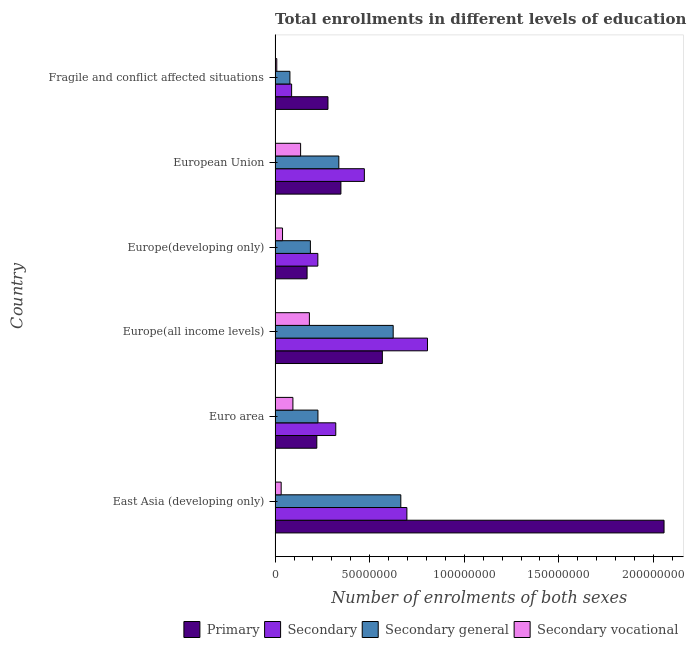Are the number of bars per tick equal to the number of legend labels?
Offer a terse response. Yes. Are the number of bars on each tick of the Y-axis equal?
Provide a short and direct response. Yes. How many bars are there on the 2nd tick from the top?
Your answer should be compact. 4. What is the label of the 3rd group of bars from the top?
Your answer should be very brief. Europe(developing only). What is the number of enrolments in secondary vocational education in East Asia (developing only)?
Your answer should be compact. 3.22e+06. Across all countries, what is the maximum number of enrolments in secondary education?
Provide a short and direct response. 8.06e+07. Across all countries, what is the minimum number of enrolments in secondary vocational education?
Give a very brief answer. 9.00e+05. In which country was the number of enrolments in primary education maximum?
Offer a very short reply. East Asia (developing only). In which country was the number of enrolments in primary education minimum?
Offer a terse response. Europe(developing only). What is the total number of enrolments in secondary education in the graph?
Offer a very short reply. 2.61e+08. What is the difference between the number of enrolments in secondary general education in Europe(all income levels) and that in European Union?
Ensure brevity in your answer.  2.87e+07. What is the difference between the number of enrolments in primary education in Europe(all income levels) and the number of enrolments in secondary general education in Fragile and conflict affected situations?
Keep it short and to the point. 4.89e+07. What is the average number of enrolments in secondary general education per country?
Provide a succinct answer. 3.53e+07. What is the difference between the number of enrolments in secondary vocational education and number of enrolments in secondary general education in East Asia (developing only)?
Give a very brief answer. -6.32e+07. What is the ratio of the number of enrolments in secondary vocational education in Europe(all income levels) to that in Fragile and conflict affected situations?
Your answer should be very brief. 20.14. Is the difference between the number of enrolments in secondary general education in Europe(all income levels) and Europe(developing only) greater than the difference between the number of enrolments in primary education in Europe(all income levels) and Europe(developing only)?
Keep it short and to the point. Yes. What is the difference between the highest and the second highest number of enrolments in primary education?
Provide a succinct answer. 1.49e+08. What is the difference between the highest and the lowest number of enrolments in secondary vocational education?
Make the answer very short. 1.72e+07. In how many countries, is the number of enrolments in secondary education greater than the average number of enrolments in secondary education taken over all countries?
Give a very brief answer. 3. Is it the case that in every country, the sum of the number of enrolments in secondary general education and number of enrolments in secondary vocational education is greater than the sum of number of enrolments in secondary education and number of enrolments in primary education?
Make the answer very short. No. What does the 2nd bar from the top in Europe(all income levels) represents?
Keep it short and to the point. Secondary general. What does the 3rd bar from the bottom in European Union represents?
Provide a succinct answer. Secondary general. How many bars are there?
Provide a short and direct response. 24. How many countries are there in the graph?
Your response must be concise. 6. What is the difference between two consecutive major ticks on the X-axis?
Offer a very short reply. 5.00e+07. Does the graph contain any zero values?
Your answer should be compact. No. Does the graph contain grids?
Keep it short and to the point. No. Where does the legend appear in the graph?
Offer a very short reply. Bottom right. How many legend labels are there?
Ensure brevity in your answer.  4. What is the title of the graph?
Provide a succinct answer. Total enrollments in different levels of education as per the survey of 1982. What is the label or title of the X-axis?
Provide a short and direct response. Number of enrolments of both sexes. What is the label or title of the Y-axis?
Ensure brevity in your answer.  Country. What is the Number of enrolments of both sexes of Primary in East Asia (developing only)?
Give a very brief answer. 2.06e+08. What is the Number of enrolments of both sexes of Secondary in East Asia (developing only)?
Your response must be concise. 6.97e+07. What is the Number of enrolments of both sexes of Secondary general in East Asia (developing only)?
Ensure brevity in your answer.  6.65e+07. What is the Number of enrolments of both sexes of Secondary vocational in East Asia (developing only)?
Provide a succinct answer. 3.22e+06. What is the Number of enrolments of both sexes of Primary in Euro area?
Ensure brevity in your answer.  2.21e+07. What is the Number of enrolments of both sexes of Secondary in Euro area?
Offer a very short reply. 3.21e+07. What is the Number of enrolments of both sexes of Secondary general in Euro area?
Your answer should be very brief. 2.27e+07. What is the Number of enrolments of both sexes of Secondary vocational in Euro area?
Your answer should be compact. 9.42e+06. What is the Number of enrolments of both sexes in Primary in Europe(all income levels)?
Offer a terse response. 5.67e+07. What is the Number of enrolments of both sexes in Secondary in Europe(all income levels)?
Offer a very short reply. 8.06e+07. What is the Number of enrolments of both sexes of Secondary general in Europe(all income levels)?
Make the answer very short. 6.24e+07. What is the Number of enrolments of both sexes of Secondary vocational in Europe(all income levels)?
Offer a very short reply. 1.81e+07. What is the Number of enrolments of both sexes of Primary in Europe(developing only)?
Offer a very short reply. 1.69e+07. What is the Number of enrolments of both sexes in Secondary in Europe(developing only)?
Your response must be concise. 2.26e+07. What is the Number of enrolments of both sexes of Secondary general in Europe(developing only)?
Give a very brief answer. 1.87e+07. What is the Number of enrolments of both sexes in Secondary vocational in Europe(developing only)?
Make the answer very short. 3.94e+06. What is the Number of enrolments of both sexes in Primary in European Union?
Your answer should be very brief. 3.48e+07. What is the Number of enrolments of both sexes in Secondary in European Union?
Your response must be concise. 4.72e+07. What is the Number of enrolments of both sexes in Secondary general in European Union?
Offer a terse response. 3.37e+07. What is the Number of enrolments of both sexes in Secondary vocational in European Union?
Ensure brevity in your answer.  1.35e+07. What is the Number of enrolments of both sexes in Primary in Fragile and conflict affected situations?
Make the answer very short. 2.80e+07. What is the Number of enrolments of both sexes of Secondary in Fragile and conflict affected situations?
Your answer should be very brief. 8.74e+06. What is the Number of enrolments of both sexes in Secondary general in Fragile and conflict affected situations?
Ensure brevity in your answer.  7.84e+06. What is the Number of enrolments of both sexes in Secondary vocational in Fragile and conflict affected situations?
Your answer should be compact. 9.00e+05. Across all countries, what is the maximum Number of enrolments of both sexes in Primary?
Provide a succinct answer. 2.06e+08. Across all countries, what is the maximum Number of enrolments of both sexes in Secondary?
Your response must be concise. 8.06e+07. Across all countries, what is the maximum Number of enrolments of both sexes in Secondary general?
Provide a short and direct response. 6.65e+07. Across all countries, what is the maximum Number of enrolments of both sexes of Secondary vocational?
Give a very brief answer. 1.81e+07. Across all countries, what is the minimum Number of enrolments of both sexes in Primary?
Your answer should be very brief. 1.69e+07. Across all countries, what is the minimum Number of enrolments of both sexes of Secondary?
Provide a short and direct response. 8.74e+06. Across all countries, what is the minimum Number of enrolments of both sexes in Secondary general?
Ensure brevity in your answer.  7.84e+06. Across all countries, what is the minimum Number of enrolments of both sexes of Secondary vocational?
Ensure brevity in your answer.  9.00e+05. What is the total Number of enrolments of both sexes of Primary in the graph?
Offer a very short reply. 3.64e+08. What is the total Number of enrolments of both sexes in Secondary in the graph?
Your answer should be very brief. 2.61e+08. What is the total Number of enrolments of both sexes in Secondary general in the graph?
Your answer should be very brief. 2.12e+08. What is the total Number of enrolments of both sexes of Secondary vocational in the graph?
Your response must be concise. 4.91e+07. What is the difference between the Number of enrolments of both sexes of Primary in East Asia (developing only) and that in Euro area?
Your response must be concise. 1.84e+08. What is the difference between the Number of enrolments of both sexes in Secondary in East Asia (developing only) and that in Euro area?
Your answer should be compact. 3.76e+07. What is the difference between the Number of enrolments of both sexes in Secondary general in East Asia (developing only) and that in Euro area?
Give a very brief answer. 4.38e+07. What is the difference between the Number of enrolments of both sexes of Secondary vocational in East Asia (developing only) and that in Euro area?
Provide a short and direct response. -6.20e+06. What is the difference between the Number of enrolments of both sexes of Primary in East Asia (developing only) and that in Europe(all income levels)?
Your response must be concise. 1.49e+08. What is the difference between the Number of enrolments of both sexes in Secondary in East Asia (developing only) and that in Europe(all income levels)?
Offer a very short reply. -1.09e+07. What is the difference between the Number of enrolments of both sexes in Secondary general in East Asia (developing only) and that in Europe(all income levels)?
Make the answer very short. 4.03e+06. What is the difference between the Number of enrolments of both sexes of Secondary vocational in East Asia (developing only) and that in Europe(all income levels)?
Ensure brevity in your answer.  -1.49e+07. What is the difference between the Number of enrolments of both sexes of Primary in East Asia (developing only) and that in Europe(developing only)?
Your answer should be very brief. 1.89e+08. What is the difference between the Number of enrolments of both sexes in Secondary in East Asia (developing only) and that in Europe(developing only)?
Provide a short and direct response. 4.71e+07. What is the difference between the Number of enrolments of both sexes of Secondary general in East Asia (developing only) and that in Europe(developing only)?
Ensure brevity in your answer.  4.78e+07. What is the difference between the Number of enrolments of both sexes of Secondary vocational in East Asia (developing only) and that in Europe(developing only)?
Your answer should be very brief. -7.19e+05. What is the difference between the Number of enrolments of both sexes in Primary in East Asia (developing only) and that in European Union?
Give a very brief answer. 1.71e+08. What is the difference between the Number of enrolments of both sexes of Secondary in East Asia (developing only) and that in European Union?
Your answer should be compact. 2.25e+07. What is the difference between the Number of enrolments of both sexes of Secondary general in East Asia (developing only) and that in European Union?
Your response must be concise. 3.28e+07. What is the difference between the Number of enrolments of both sexes of Secondary vocational in East Asia (developing only) and that in European Union?
Provide a short and direct response. -1.03e+07. What is the difference between the Number of enrolments of both sexes of Primary in East Asia (developing only) and that in Fragile and conflict affected situations?
Keep it short and to the point. 1.78e+08. What is the difference between the Number of enrolments of both sexes in Secondary in East Asia (developing only) and that in Fragile and conflict affected situations?
Provide a short and direct response. 6.09e+07. What is the difference between the Number of enrolments of both sexes in Secondary general in East Asia (developing only) and that in Fragile and conflict affected situations?
Offer a terse response. 5.86e+07. What is the difference between the Number of enrolments of both sexes of Secondary vocational in East Asia (developing only) and that in Fragile and conflict affected situations?
Keep it short and to the point. 2.32e+06. What is the difference between the Number of enrolments of both sexes of Primary in Euro area and that in Europe(all income levels)?
Offer a very short reply. -3.46e+07. What is the difference between the Number of enrolments of both sexes in Secondary in Euro area and that in Europe(all income levels)?
Provide a succinct answer. -4.85e+07. What is the difference between the Number of enrolments of both sexes of Secondary general in Euro area and that in Europe(all income levels)?
Provide a short and direct response. -3.98e+07. What is the difference between the Number of enrolments of both sexes of Secondary vocational in Euro area and that in Europe(all income levels)?
Make the answer very short. -8.71e+06. What is the difference between the Number of enrolments of both sexes in Primary in Euro area and that in Europe(developing only)?
Make the answer very short. 5.14e+06. What is the difference between the Number of enrolments of both sexes of Secondary in Euro area and that in Europe(developing only)?
Your response must be concise. 9.47e+06. What is the difference between the Number of enrolments of both sexes of Secondary general in Euro area and that in Europe(developing only)?
Keep it short and to the point. 3.99e+06. What is the difference between the Number of enrolments of both sexes of Secondary vocational in Euro area and that in Europe(developing only)?
Make the answer very short. 5.48e+06. What is the difference between the Number of enrolments of both sexes of Primary in Euro area and that in European Union?
Ensure brevity in your answer.  -1.27e+07. What is the difference between the Number of enrolments of both sexes of Secondary in Euro area and that in European Union?
Make the answer very short. -1.51e+07. What is the difference between the Number of enrolments of both sexes of Secondary general in Euro area and that in European Union?
Ensure brevity in your answer.  -1.10e+07. What is the difference between the Number of enrolments of both sexes of Secondary vocational in Euro area and that in European Union?
Your answer should be compact. -4.08e+06. What is the difference between the Number of enrolments of both sexes of Primary in Euro area and that in Fragile and conflict affected situations?
Your response must be concise. -5.90e+06. What is the difference between the Number of enrolments of both sexes of Secondary in Euro area and that in Fragile and conflict affected situations?
Give a very brief answer. 2.33e+07. What is the difference between the Number of enrolments of both sexes in Secondary general in Euro area and that in Fragile and conflict affected situations?
Provide a succinct answer. 1.48e+07. What is the difference between the Number of enrolments of both sexes in Secondary vocational in Euro area and that in Fragile and conflict affected situations?
Provide a succinct answer. 8.52e+06. What is the difference between the Number of enrolments of both sexes of Primary in Europe(all income levels) and that in Europe(developing only)?
Provide a short and direct response. 3.98e+07. What is the difference between the Number of enrolments of both sexes of Secondary in Europe(all income levels) and that in Europe(developing only)?
Your answer should be very brief. 5.80e+07. What is the difference between the Number of enrolments of both sexes of Secondary general in Europe(all income levels) and that in Europe(developing only)?
Your answer should be very brief. 4.38e+07. What is the difference between the Number of enrolments of both sexes in Secondary vocational in Europe(all income levels) and that in Europe(developing only)?
Offer a very short reply. 1.42e+07. What is the difference between the Number of enrolments of both sexes in Primary in Europe(all income levels) and that in European Union?
Offer a terse response. 2.19e+07. What is the difference between the Number of enrolments of both sexes in Secondary in Europe(all income levels) and that in European Union?
Make the answer very short. 3.34e+07. What is the difference between the Number of enrolments of both sexes of Secondary general in Europe(all income levels) and that in European Union?
Ensure brevity in your answer.  2.87e+07. What is the difference between the Number of enrolments of both sexes in Secondary vocational in Europe(all income levels) and that in European Union?
Make the answer very short. 4.64e+06. What is the difference between the Number of enrolments of both sexes of Primary in Europe(all income levels) and that in Fragile and conflict affected situations?
Ensure brevity in your answer.  2.87e+07. What is the difference between the Number of enrolments of both sexes of Secondary in Europe(all income levels) and that in Fragile and conflict affected situations?
Provide a succinct answer. 7.18e+07. What is the difference between the Number of enrolments of both sexes of Secondary general in Europe(all income levels) and that in Fragile and conflict affected situations?
Your answer should be compact. 5.46e+07. What is the difference between the Number of enrolments of both sexes in Secondary vocational in Europe(all income levels) and that in Fragile and conflict affected situations?
Make the answer very short. 1.72e+07. What is the difference between the Number of enrolments of both sexes of Primary in Europe(developing only) and that in European Union?
Provide a succinct answer. -1.79e+07. What is the difference between the Number of enrolments of both sexes in Secondary in Europe(developing only) and that in European Union?
Give a very brief answer. -2.46e+07. What is the difference between the Number of enrolments of both sexes of Secondary general in Europe(developing only) and that in European Union?
Give a very brief answer. -1.50e+07. What is the difference between the Number of enrolments of both sexes in Secondary vocational in Europe(developing only) and that in European Union?
Offer a very short reply. -9.56e+06. What is the difference between the Number of enrolments of both sexes in Primary in Europe(developing only) and that in Fragile and conflict affected situations?
Your answer should be very brief. -1.10e+07. What is the difference between the Number of enrolments of both sexes in Secondary in Europe(developing only) and that in Fragile and conflict affected situations?
Provide a short and direct response. 1.39e+07. What is the difference between the Number of enrolments of both sexes in Secondary general in Europe(developing only) and that in Fragile and conflict affected situations?
Your answer should be very brief. 1.08e+07. What is the difference between the Number of enrolments of both sexes of Secondary vocational in Europe(developing only) and that in Fragile and conflict affected situations?
Make the answer very short. 3.04e+06. What is the difference between the Number of enrolments of both sexes of Primary in European Union and that in Fragile and conflict affected situations?
Your response must be concise. 6.83e+06. What is the difference between the Number of enrolments of both sexes of Secondary in European Union and that in Fragile and conflict affected situations?
Keep it short and to the point. 3.85e+07. What is the difference between the Number of enrolments of both sexes in Secondary general in European Union and that in Fragile and conflict affected situations?
Ensure brevity in your answer.  2.59e+07. What is the difference between the Number of enrolments of both sexes of Secondary vocational in European Union and that in Fragile and conflict affected situations?
Make the answer very short. 1.26e+07. What is the difference between the Number of enrolments of both sexes of Primary in East Asia (developing only) and the Number of enrolments of both sexes of Secondary in Euro area?
Keep it short and to the point. 1.74e+08. What is the difference between the Number of enrolments of both sexes of Primary in East Asia (developing only) and the Number of enrolments of both sexes of Secondary general in Euro area?
Offer a very short reply. 1.83e+08. What is the difference between the Number of enrolments of both sexes of Primary in East Asia (developing only) and the Number of enrolments of both sexes of Secondary vocational in Euro area?
Keep it short and to the point. 1.96e+08. What is the difference between the Number of enrolments of both sexes in Secondary in East Asia (developing only) and the Number of enrolments of both sexes in Secondary general in Euro area?
Offer a very short reply. 4.70e+07. What is the difference between the Number of enrolments of both sexes of Secondary in East Asia (developing only) and the Number of enrolments of both sexes of Secondary vocational in Euro area?
Your answer should be very brief. 6.03e+07. What is the difference between the Number of enrolments of both sexes of Secondary general in East Asia (developing only) and the Number of enrolments of both sexes of Secondary vocational in Euro area?
Offer a very short reply. 5.70e+07. What is the difference between the Number of enrolments of both sexes of Primary in East Asia (developing only) and the Number of enrolments of both sexes of Secondary in Europe(all income levels)?
Offer a very short reply. 1.25e+08. What is the difference between the Number of enrolments of both sexes of Primary in East Asia (developing only) and the Number of enrolments of both sexes of Secondary general in Europe(all income levels)?
Keep it short and to the point. 1.43e+08. What is the difference between the Number of enrolments of both sexes of Primary in East Asia (developing only) and the Number of enrolments of both sexes of Secondary vocational in Europe(all income levels)?
Offer a very short reply. 1.87e+08. What is the difference between the Number of enrolments of both sexes of Secondary in East Asia (developing only) and the Number of enrolments of both sexes of Secondary general in Europe(all income levels)?
Provide a succinct answer. 7.25e+06. What is the difference between the Number of enrolments of both sexes of Secondary in East Asia (developing only) and the Number of enrolments of both sexes of Secondary vocational in Europe(all income levels)?
Your answer should be compact. 5.15e+07. What is the difference between the Number of enrolments of both sexes of Secondary general in East Asia (developing only) and the Number of enrolments of both sexes of Secondary vocational in Europe(all income levels)?
Ensure brevity in your answer.  4.83e+07. What is the difference between the Number of enrolments of both sexes in Primary in East Asia (developing only) and the Number of enrolments of both sexes in Secondary in Europe(developing only)?
Offer a terse response. 1.83e+08. What is the difference between the Number of enrolments of both sexes of Primary in East Asia (developing only) and the Number of enrolments of both sexes of Secondary general in Europe(developing only)?
Keep it short and to the point. 1.87e+08. What is the difference between the Number of enrolments of both sexes in Primary in East Asia (developing only) and the Number of enrolments of both sexes in Secondary vocational in Europe(developing only)?
Your answer should be very brief. 2.02e+08. What is the difference between the Number of enrolments of both sexes of Secondary in East Asia (developing only) and the Number of enrolments of both sexes of Secondary general in Europe(developing only)?
Ensure brevity in your answer.  5.10e+07. What is the difference between the Number of enrolments of both sexes of Secondary in East Asia (developing only) and the Number of enrolments of both sexes of Secondary vocational in Europe(developing only)?
Your answer should be compact. 6.57e+07. What is the difference between the Number of enrolments of both sexes in Secondary general in East Asia (developing only) and the Number of enrolments of both sexes in Secondary vocational in Europe(developing only)?
Give a very brief answer. 6.25e+07. What is the difference between the Number of enrolments of both sexes of Primary in East Asia (developing only) and the Number of enrolments of both sexes of Secondary in European Union?
Give a very brief answer. 1.58e+08. What is the difference between the Number of enrolments of both sexes in Primary in East Asia (developing only) and the Number of enrolments of both sexes in Secondary general in European Union?
Provide a short and direct response. 1.72e+08. What is the difference between the Number of enrolments of both sexes of Primary in East Asia (developing only) and the Number of enrolments of both sexes of Secondary vocational in European Union?
Make the answer very short. 1.92e+08. What is the difference between the Number of enrolments of both sexes of Secondary in East Asia (developing only) and the Number of enrolments of both sexes of Secondary general in European Union?
Make the answer very short. 3.60e+07. What is the difference between the Number of enrolments of both sexes in Secondary in East Asia (developing only) and the Number of enrolments of both sexes in Secondary vocational in European Union?
Your answer should be compact. 5.62e+07. What is the difference between the Number of enrolments of both sexes in Secondary general in East Asia (developing only) and the Number of enrolments of both sexes in Secondary vocational in European Union?
Offer a terse response. 5.30e+07. What is the difference between the Number of enrolments of both sexes of Primary in East Asia (developing only) and the Number of enrolments of both sexes of Secondary in Fragile and conflict affected situations?
Keep it short and to the point. 1.97e+08. What is the difference between the Number of enrolments of both sexes of Primary in East Asia (developing only) and the Number of enrolments of both sexes of Secondary general in Fragile and conflict affected situations?
Make the answer very short. 1.98e+08. What is the difference between the Number of enrolments of both sexes in Primary in East Asia (developing only) and the Number of enrolments of both sexes in Secondary vocational in Fragile and conflict affected situations?
Your answer should be very brief. 2.05e+08. What is the difference between the Number of enrolments of both sexes of Secondary in East Asia (developing only) and the Number of enrolments of both sexes of Secondary general in Fragile and conflict affected situations?
Give a very brief answer. 6.18e+07. What is the difference between the Number of enrolments of both sexes of Secondary in East Asia (developing only) and the Number of enrolments of both sexes of Secondary vocational in Fragile and conflict affected situations?
Offer a very short reply. 6.88e+07. What is the difference between the Number of enrolments of both sexes of Secondary general in East Asia (developing only) and the Number of enrolments of both sexes of Secondary vocational in Fragile and conflict affected situations?
Ensure brevity in your answer.  6.56e+07. What is the difference between the Number of enrolments of both sexes in Primary in Euro area and the Number of enrolments of both sexes in Secondary in Europe(all income levels)?
Your answer should be very brief. -5.85e+07. What is the difference between the Number of enrolments of both sexes of Primary in Euro area and the Number of enrolments of both sexes of Secondary general in Europe(all income levels)?
Keep it short and to the point. -4.04e+07. What is the difference between the Number of enrolments of both sexes in Primary in Euro area and the Number of enrolments of both sexes in Secondary vocational in Europe(all income levels)?
Provide a short and direct response. 3.93e+06. What is the difference between the Number of enrolments of both sexes of Secondary in Euro area and the Number of enrolments of both sexes of Secondary general in Europe(all income levels)?
Provide a succinct answer. -3.04e+07. What is the difference between the Number of enrolments of both sexes in Secondary in Euro area and the Number of enrolments of both sexes in Secondary vocational in Europe(all income levels)?
Your answer should be very brief. 1.39e+07. What is the difference between the Number of enrolments of both sexes of Secondary general in Euro area and the Number of enrolments of both sexes of Secondary vocational in Europe(all income levels)?
Offer a very short reply. 4.52e+06. What is the difference between the Number of enrolments of both sexes of Primary in Euro area and the Number of enrolments of both sexes of Secondary in Europe(developing only)?
Your answer should be compact. -5.44e+05. What is the difference between the Number of enrolments of both sexes of Primary in Euro area and the Number of enrolments of both sexes of Secondary general in Europe(developing only)?
Offer a very short reply. 3.39e+06. What is the difference between the Number of enrolments of both sexes in Primary in Euro area and the Number of enrolments of both sexes in Secondary vocational in Europe(developing only)?
Provide a short and direct response. 1.81e+07. What is the difference between the Number of enrolments of both sexes in Secondary in Euro area and the Number of enrolments of both sexes in Secondary general in Europe(developing only)?
Keep it short and to the point. 1.34e+07. What is the difference between the Number of enrolments of both sexes in Secondary in Euro area and the Number of enrolments of both sexes in Secondary vocational in Europe(developing only)?
Ensure brevity in your answer.  2.81e+07. What is the difference between the Number of enrolments of both sexes in Secondary general in Euro area and the Number of enrolments of both sexes in Secondary vocational in Europe(developing only)?
Provide a succinct answer. 1.87e+07. What is the difference between the Number of enrolments of both sexes in Primary in Euro area and the Number of enrolments of both sexes in Secondary in European Union?
Make the answer very short. -2.51e+07. What is the difference between the Number of enrolments of both sexes in Primary in Euro area and the Number of enrolments of both sexes in Secondary general in European Union?
Keep it short and to the point. -1.16e+07. What is the difference between the Number of enrolments of both sexes in Primary in Euro area and the Number of enrolments of both sexes in Secondary vocational in European Union?
Make the answer very short. 8.57e+06. What is the difference between the Number of enrolments of both sexes of Secondary in Euro area and the Number of enrolments of both sexes of Secondary general in European Union?
Your response must be concise. -1.62e+06. What is the difference between the Number of enrolments of both sexes in Secondary in Euro area and the Number of enrolments of both sexes in Secondary vocational in European Union?
Give a very brief answer. 1.86e+07. What is the difference between the Number of enrolments of both sexes in Secondary general in Euro area and the Number of enrolments of both sexes in Secondary vocational in European Union?
Provide a short and direct response. 9.16e+06. What is the difference between the Number of enrolments of both sexes in Primary in Euro area and the Number of enrolments of both sexes in Secondary in Fragile and conflict affected situations?
Keep it short and to the point. 1.33e+07. What is the difference between the Number of enrolments of both sexes in Primary in Euro area and the Number of enrolments of both sexes in Secondary general in Fragile and conflict affected situations?
Provide a short and direct response. 1.42e+07. What is the difference between the Number of enrolments of both sexes in Primary in Euro area and the Number of enrolments of both sexes in Secondary vocational in Fragile and conflict affected situations?
Give a very brief answer. 2.12e+07. What is the difference between the Number of enrolments of both sexes in Secondary in Euro area and the Number of enrolments of both sexes in Secondary general in Fragile and conflict affected situations?
Make the answer very short. 2.42e+07. What is the difference between the Number of enrolments of both sexes in Secondary in Euro area and the Number of enrolments of both sexes in Secondary vocational in Fragile and conflict affected situations?
Offer a terse response. 3.12e+07. What is the difference between the Number of enrolments of both sexes of Secondary general in Euro area and the Number of enrolments of both sexes of Secondary vocational in Fragile and conflict affected situations?
Your response must be concise. 2.18e+07. What is the difference between the Number of enrolments of both sexes in Primary in Europe(all income levels) and the Number of enrolments of both sexes in Secondary in Europe(developing only)?
Your answer should be very brief. 3.41e+07. What is the difference between the Number of enrolments of both sexes of Primary in Europe(all income levels) and the Number of enrolments of both sexes of Secondary general in Europe(developing only)?
Make the answer very short. 3.80e+07. What is the difference between the Number of enrolments of both sexes in Primary in Europe(all income levels) and the Number of enrolments of both sexes in Secondary vocational in Europe(developing only)?
Offer a terse response. 5.28e+07. What is the difference between the Number of enrolments of both sexes in Secondary in Europe(all income levels) and the Number of enrolments of both sexes in Secondary general in Europe(developing only)?
Offer a very short reply. 6.19e+07. What is the difference between the Number of enrolments of both sexes in Secondary in Europe(all income levels) and the Number of enrolments of both sexes in Secondary vocational in Europe(developing only)?
Make the answer very short. 7.66e+07. What is the difference between the Number of enrolments of both sexes in Secondary general in Europe(all income levels) and the Number of enrolments of both sexes in Secondary vocational in Europe(developing only)?
Give a very brief answer. 5.85e+07. What is the difference between the Number of enrolments of both sexes in Primary in Europe(all income levels) and the Number of enrolments of both sexes in Secondary in European Union?
Keep it short and to the point. 9.52e+06. What is the difference between the Number of enrolments of both sexes in Primary in Europe(all income levels) and the Number of enrolments of both sexes in Secondary general in European Union?
Keep it short and to the point. 2.30e+07. What is the difference between the Number of enrolments of both sexes of Primary in Europe(all income levels) and the Number of enrolments of both sexes of Secondary vocational in European Union?
Give a very brief answer. 4.32e+07. What is the difference between the Number of enrolments of both sexes of Secondary in Europe(all income levels) and the Number of enrolments of both sexes of Secondary general in European Union?
Provide a short and direct response. 4.69e+07. What is the difference between the Number of enrolments of both sexes of Secondary in Europe(all income levels) and the Number of enrolments of both sexes of Secondary vocational in European Union?
Offer a terse response. 6.71e+07. What is the difference between the Number of enrolments of both sexes of Secondary general in Europe(all income levels) and the Number of enrolments of both sexes of Secondary vocational in European Union?
Make the answer very short. 4.89e+07. What is the difference between the Number of enrolments of both sexes in Primary in Europe(all income levels) and the Number of enrolments of both sexes in Secondary in Fragile and conflict affected situations?
Ensure brevity in your answer.  4.80e+07. What is the difference between the Number of enrolments of both sexes in Primary in Europe(all income levels) and the Number of enrolments of both sexes in Secondary general in Fragile and conflict affected situations?
Your answer should be compact. 4.89e+07. What is the difference between the Number of enrolments of both sexes of Primary in Europe(all income levels) and the Number of enrolments of both sexes of Secondary vocational in Fragile and conflict affected situations?
Keep it short and to the point. 5.58e+07. What is the difference between the Number of enrolments of both sexes in Secondary in Europe(all income levels) and the Number of enrolments of both sexes in Secondary general in Fragile and conflict affected situations?
Keep it short and to the point. 7.27e+07. What is the difference between the Number of enrolments of both sexes of Secondary in Europe(all income levels) and the Number of enrolments of both sexes of Secondary vocational in Fragile and conflict affected situations?
Your answer should be very brief. 7.97e+07. What is the difference between the Number of enrolments of both sexes of Secondary general in Europe(all income levels) and the Number of enrolments of both sexes of Secondary vocational in Fragile and conflict affected situations?
Provide a succinct answer. 6.15e+07. What is the difference between the Number of enrolments of both sexes in Primary in Europe(developing only) and the Number of enrolments of both sexes in Secondary in European Union?
Ensure brevity in your answer.  -3.03e+07. What is the difference between the Number of enrolments of both sexes of Primary in Europe(developing only) and the Number of enrolments of both sexes of Secondary general in European Union?
Keep it short and to the point. -1.68e+07. What is the difference between the Number of enrolments of both sexes of Primary in Europe(developing only) and the Number of enrolments of both sexes of Secondary vocational in European Union?
Ensure brevity in your answer.  3.42e+06. What is the difference between the Number of enrolments of both sexes of Secondary in Europe(developing only) and the Number of enrolments of both sexes of Secondary general in European Union?
Make the answer very short. -1.11e+07. What is the difference between the Number of enrolments of both sexes in Secondary in Europe(developing only) and the Number of enrolments of both sexes in Secondary vocational in European Union?
Make the answer very short. 9.11e+06. What is the difference between the Number of enrolments of both sexes of Secondary general in Europe(developing only) and the Number of enrolments of both sexes of Secondary vocational in European Union?
Offer a terse response. 5.17e+06. What is the difference between the Number of enrolments of both sexes in Primary in Europe(developing only) and the Number of enrolments of both sexes in Secondary in Fragile and conflict affected situations?
Make the answer very short. 8.18e+06. What is the difference between the Number of enrolments of both sexes of Primary in Europe(developing only) and the Number of enrolments of both sexes of Secondary general in Fragile and conflict affected situations?
Offer a terse response. 9.08e+06. What is the difference between the Number of enrolments of both sexes of Primary in Europe(developing only) and the Number of enrolments of both sexes of Secondary vocational in Fragile and conflict affected situations?
Your answer should be compact. 1.60e+07. What is the difference between the Number of enrolments of both sexes in Secondary in Europe(developing only) and the Number of enrolments of both sexes in Secondary general in Fragile and conflict affected situations?
Keep it short and to the point. 1.48e+07. What is the difference between the Number of enrolments of both sexes in Secondary in Europe(developing only) and the Number of enrolments of both sexes in Secondary vocational in Fragile and conflict affected situations?
Provide a succinct answer. 2.17e+07. What is the difference between the Number of enrolments of both sexes of Secondary general in Europe(developing only) and the Number of enrolments of both sexes of Secondary vocational in Fragile and conflict affected situations?
Your response must be concise. 1.78e+07. What is the difference between the Number of enrolments of both sexes in Primary in European Union and the Number of enrolments of both sexes in Secondary in Fragile and conflict affected situations?
Ensure brevity in your answer.  2.61e+07. What is the difference between the Number of enrolments of both sexes of Primary in European Union and the Number of enrolments of both sexes of Secondary general in Fragile and conflict affected situations?
Offer a very short reply. 2.70e+07. What is the difference between the Number of enrolments of both sexes in Primary in European Union and the Number of enrolments of both sexes in Secondary vocational in Fragile and conflict affected situations?
Your response must be concise. 3.39e+07. What is the difference between the Number of enrolments of both sexes in Secondary in European Union and the Number of enrolments of both sexes in Secondary general in Fragile and conflict affected situations?
Your answer should be very brief. 3.94e+07. What is the difference between the Number of enrolments of both sexes in Secondary in European Union and the Number of enrolments of both sexes in Secondary vocational in Fragile and conflict affected situations?
Offer a terse response. 4.63e+07. What is the difference between the Number of enrolments of both sexes of Secondary general in European Union and the Number of enrolments of both sexes of Secondary vocational in Fragile and conflict affected situations?
Give a very brief answer. 3.28e+07. What is the average Number of enrolments of both sexes of Primary per country?
Ensure brevity in your answer.  6.07e+07. What is the average Number of enrolments of both sexes of Secondary per country?
Make the answer very short. 4.35e+07. What is the average Number of enrolments of both sexes in Secondary general per country?
Offer a very short reply. 3.53e+07. What is the average Number of enrolments of both sexes in Secondary vocational per country?
Your answer should be compact. 8.18e+06. What is the difference between the Number of enrolments of both sexes of Primary and Number of enrolments of both sexes of Secondary in East Asia (developing only)?
Your response must be concise. 1.36e+08. What is the difference between the Number of enrolments of both sexes in Primary and Number of enrolments of both sexes in Secondary general in East Asia (developing only)?
Make the answer very short. 1.39e+08. What is the difference between the Number of enrolments of both sexes in Primary and Number of enrolments of both sexes in Secondary vocational in East Asia (developing only)?
Your response must be concise. 2.02e+08. What is the difference between the Number of enrolments of both sexes of Secondary and Number of enrolments of both sexes of Secondary general in East Asia (developing only)?
Offer a terse response. 3.22e+06. What is the difference between the Number of enrolments of both sexes of Secondary and Number of enrolments of both sexes of Secondary vocational in East Asia (developing only)?
Keep it short and to the point. 6.65e+07. What is the difference between the Number of enrolments of both sexes of Secondary general and Number of enrolments of both sexes of Secondary vocational in East Asia (developing only)?
Your answer should be very brief. 6.32e+07. What is the difference between the Number of enrolments of both sexes of Primary and Number of enrolments of both sexes of Secondary in Euro area?
Offer a terse response. -1.00e+07. What is the difference between the Number of enrolments of both sexes of Primary and Number of enrolments of both sexes of Secondary general in Euro area?
Offer a very short reply. -5.94e+05. What is the difference between the Number of enrolments of both sexes in Primary and Number of enrolments of both sexes in Secondary vocational in Euro area?
Offer a very short reply. 1.26e+07. What is the difference between the Number of enrolments of both sexes in Secondary and Number of enrolments of both sexes in Secondary general in Euro area?
Provide a succinct answer. 9.42e+06. What is the difference between the Number of enrolments of both sexes in Secondary and Number of enrolments of both sexes in Secondary vocational in Euro area?
Offer a terse response. 2.27e+07. What is the difference between the Number of enrolments of both sexes of Secondary general and Number of enrolments of both sexes of Secondary vocational in Euro area?
Provide a succinct answer. 1.32e+07. What is the difference between the Number of enrolments of both sexes in Primary and Number of enrolments of both sexes in Secondary in Europe(all income levels)?
Offer a very short reply. -2.39e+07. What is the difference between the Number of enrolments of both sexes of Primary and Number of enrolments of both sexes of Secondary general in Europe(all income levels)?
Your answer should be compact. -5.72e+06. What is the difference between the Number of enrolments of both sexes of Primary and Number of enrolments of both sexes of Secondary vocational in Europe(all income levels)?
Provide a short and direct response. 3.86e+07. What is the difference between the Number of enrolments of both sexes of Secondary and Number of enrolments of both sexes of Secondary general in Europe(all income levels)?
Keep it short and to the point. 1.81e+07. What is the difference between the Number of enrolments of both sexes of Secondary and Number of enrolments of both sexes of Secondary vocational in Europe(all income levels)?
Your response must be concise. 6.24e+07. What is the difference between the Number of enrolments of both sexes in Secondary general and Number of enrolments of both sexes in Secondary vocational in Europe(all income levels)?
Your response must be concise. 4.43e+07. What is the difference between the Number of enrolments of both sexes of Primary and Number of enrolments of both sexes of Secondary in Europe(developing only)?
Make the answer very short. -5.69e+06. What is the difference between the Number of enrolments of both sexes of Primary and Number of enrolments of both sexes of Secondary general in Europe(developing only)?
Provide a succinct answer. -1.75e+06. What is the difference between the Number of enrolments of both sexes in Primary and Number of enrolments of both sexes in Secondary vocational in Europe(developing only)?
Provide a short and direct response. 1.30e+07. What is the difference between the Number of enrolments of both sexes of Secondary and Number of enrolments of both sexes of Secondary general in Europe(developing only)?
Offer a terse response. 3.94e+06. What is the difference between the Number of enrolments of both sexes in Secondary and Number of enrolments of both sexes in Secondary vocational in Europe(developing only)?
Ensure brevity in your answer.  1.87e+07. What is the difference between the Number of enrolments of both sexes in Secondary general and Number of enrolments of both sexes in Secondary vocational in Europe(developing only)?
Your answer should be compact. 1.47e+07. What is the difference between the Number of enrolments of both sexes in Primary and Number of enrolments of both sexes in Secondary in European Union?
Provide a succinct answer. -1.24e+07. What is the difference between the Number of enrolments of both sexes in Primary and Number of enrolments of both sexes in Secondary general in European Union?
Your answer should be very brief. 1.10e+06. What is the difference between the Number of enrolments of both sexes of Primary and Number of enrolments of both sexes of Secondary vocational in European Union?
Provide a short and direct response. 2.13e+07. What is the difference between the Number of enrolments of both sexes in Secondary and Number of enrolments of both sexes in Secondary general in European Union?
Offer a terse response. 1.35e+07. What is the difference between the Number of enrolments of both sexes of Secondary and Number of enrolments of both sexes of Secondary vocational in European Union?
Offer a terse response. 3.37e+07. What is the difference between the Number of enrolments of both sexes in Secondary general and Number of enrolments of both sexes in Secondary vocational in European Union?
Make the answer very short. 2.02e+07. What is the difference between the Number of enrolments of both sexes in Primary and Number of enrolments of both sexes in Secondary in Fragile and conflict affected situations?
Your answer should be compact. 1.92e+07. What is the difference between the Number of enrolments of both sexes in Primary and Number of enrolments of both sexes in Secondary general in Fragile and conflict affected situations?
Provide a succinct answer. 2.01e+07. What is the difference between the Number of enrolments of both sexes of Primary and Number of enrolments of both sexes of Secondary vocational in Fragile and conflict affected situations?
Make the answer very short. 2.71e+07. What is the difference between the Number of enrolments of both sexes of Secondary and Number of enrolments of both sexes of Secondary general in Fragile and conflict affected situations?
Your answer should be very brief. 9.00e+05. What is the difference between the Number of enrolments of both sexes of Secondary and Number of enrolments of both sexes of Secondary vocational in Fragile and conflict affected situations?
Make the answer very short. 7.84e+06. What is the difference between the Number of enrolments of both sexes of Secondary general and Number of enrolments of both sexes of Secondary vocational in Fragile and conflict affected situations?
Make the answer very short. 6.94e+06. What is the ratio of the Number of enrolments of both sexes in Primary in East Asia (developing only) to that in Euro area?
Your answer should be very brief. 9.32. What is the ratio of the Number of enrolments of both sexes of Secondary in East Asia (developing only) to that in Euro area?
Your answer should be very brief. 2.17. What is the ratio of the Number of enrolments of both sexes in Secondary general in East Asia (developing only) to that in Euro area?
Provide a short and direct response. 2.93. What is the ratio of the Number of enrolments of both sexes in Secondary vocational in East Asia (developing only) to that in Euro area?
Offer a terse response. 0.34. What is the ratio of the Number of enrolments of both sexes in Primary in East Asia (developing only) to that in Europe(all income levels)?
Make the answer very short. 3.63. What is the ratio of the Number of enrolments of both sexes in Secondary in East Asia (developing only) to that in Europe(all income levels)?
Keep it short and to the point. 0.86. What is the ratio of the Number of enrolments of both sexes in Secondary general in East Asia (developing only) to that in Europe(all income levels)?
Offer a terse response. 1.06. What is the ratio of the Number of enrolments of both sexes in Secondary vocational in East Asia (developing only) to that in Europe(all income levels)?
Ensure brevity in your answer.  0.18. What is the ratio of the Number of enrolments of both sexes in Primary in East Asia (developing only) to that in Europe(developing only)?
Give a very brief answer. 12.15. What is the ratio of the Number of enrolments of both sexes in Secondary in East Asia (developing only) to that in Europe(developing only)?
Keep it short and to the point. 3.08. What is the ratio of the Number of enrolments of both sexes of Secondary general in East Asia (developing only) to that in Europe(developing only)?
Give a very brief answer. 3.56. What is the ratio of the Number of enrolments of both sexes of Secondary vocational in East Asia (developing only) to that in Europe(developing only)?
Keep it short and to the point. 0.82. What is the ratio of the Number of enrolments of both sexes in Primary in East Asia (developing only) to that in European Union?
Your answer should be compact. 5.91. What is the ratio of the Number of enrolments of both sexes in Secondary in East Asia (developing only) to that in European Union?
Your answer should be very brief. 1.48. What is the ratio of the Number of enrolments of both sexes of Secondary general in East Asia (developing only) to that in European Union?
Ensure brevity in your answer.  1.97. What is the ratio of the Number of enrolments of both sexes of Secondary vocational in East Asia (developing only) to that in European Union?
Make the answer very short. 0.24. What is the ratio of the Number of enrolments of both sexes in Primary in East Asia (developing only) to that in Fragile and conflict affected situations?
Offer a very short reply. 7.35. What is the ratio of the Number of enrolments of both sexes in Secondary in East Asia (developing only) to that in Fragile and conflict affected situations?
Make the answer very short. 7.97. What is the ratio of the Number of enrolments of both sexes in Secondary general in East Asia (developing only) to that in Fragile and conflict affected situations?
Your answer should be very brief. 8.47. What is the ratio of the Number of enrolments of both sexes in Secondary vocational in East Asia (developing only) to that in Fragile and conflict affected situations?
Your response must be concise. 3.58. What is the ratio of the Number of enrolments of both sexes of Primary in Euro area to that in Europe(all income levels)?
Give a very brief answer. 0.39. What is the ratio of the Number of enrolments of both sexes of Secondary in Euro area to that in Europe(all income levels)?
Your answer should be very brief. 0.4. What is the ratio of the Number of enrolments of both sexes of Secondary general in Euro area to that in Europe(all income levels)?
Provide a succinct answer. 0.36. What is the ratio of the Number of enrolments of both sexes in Secondary vocational in Euro area to that in Europe(all income levels)?
Offer a very short reply. 0.52. What is the ratio of the Number of enrolments of both sexes of Primary in Euro area to that in Europe(developing only)?
Your answer should be compact. 1.3. What is the ratio of the Number of enrolments of both sexes of Secondary in Euro area to that in Europe(developing only)?
Offer a very short reply. 1.42. What is the ratio of the Number of enrolments of both sexes of Secondary general in Euro area to that in Europe(developing only)?
Your response must be concise. 1.21. What is the ratio of the Number of enrolments of both sexes in Secondary vocational in Euro area to that in Europe(developing only)?
Offer a very short reply. 2.39. What is the ratio of the Number of enrolments of both sexes of Primary in Euro area to that in European Union?
Keep it short and to the point. 0.63. What is the ratio of the Number of enrolments of both sexes in Secondary in Euro area to that in European Union?
Your response must be concise. 0.68. What is the ratio of the Number of enrolments of both sexes in Secondary general in Euro area to that in European Union?
Ensure brevity in your answer.  0.67. What is the ratio of the Number of enrolments of both sexes in Secondary vocational in Euro area to that in European Union?
Give a very brief answer. 0.7. What is the ratio of the Number of enrolments of both sexes of Primary in Euro area to that in Fragile and conflict affected situations?
Offer a terse response. 0.79. What is the ratio of the Number of enrolments of both sexes of Secondary in Euro area to that in Fragile and conflict affected situations?
Make the answer very short. 3.67. What is the ratio of the Number of enrolments of both sexes of Secondary general in Euro area to that in Fragile and conflict affected situations?
Your answer should be very brief. 2.89. What is the ratio of the Number of enrolments of both sexes in Secondary vocational in Euro area to that in Fragile and conflict affected situations?
Offer a very short reply. 10.46. What is the ratio of the Number of enrolments of both sexes of Primary in Europe(all income levels) to that in Europe(developing only)?
Provide a short and direct response. 3.35. What is the ratio of the Number of enrolments of both sexes in Secondary in Europe(all income levels) to that in Europe(developing only)?
Ensure brevity in your answer.  3.56. What is the ratio of the Number of enrolments of both sexes in Secondary general in Europe(all income levels) to that in Europe(developing only)?
Give a very brief answer. 3.34. What is the ratio of the Number of enrolments of both sexes of Secondary vocational in Europe(all income levels) to that in Europe(developing only)?
Your answer should be very brief. 4.6. What is the ratio of the Number of enrolments of both sexes of Primary in Europe(all income levels) to that in European Union?
Make the answer very short. 1.63. What is the ratio of the Number of enrolments of both sexes in Secondary in Europe(all income levels) to that in European Union?
Offer a terse response. 1.71. What is the ratio of the Number of enrolments of both sexes of Secondary general in Europe(all income levels) to that in European Union?
Your answer should be very brief. 1.85. What is the ratio of the Number of enrolments of both sexes in Secondary vocational in Europe(all income levels) to that in European Union?
Ensure brevity in your answer.  1.34. What is the ratio of the Number of enrolments of both sexes in Primary in Europe(all income levels) to that in Fragile and conflict affected situations?
Keep it short and to the point. 2.03. What is the ratio of the Number of enrolments of both sexes in Secondary in Europe(all income levels) to that in Fragile and conflict affected situations?
Ensure brevity in your answer.  9.21. What is the ratio of the Number of enrolments of both sexes in Secondary general in Europe(all income levels) to that in Fragile and conflict affected situations?
Your answer should be compact. 7.96. What is the ratio of the Number of enrolments of both sexes of Secondary vocational in Europe(all income levels) to that in Fragile and conflict affected situations?
Offer a very short reply. 20.14. What is the ratio of the Number of enrolments of both sexes of Primary in Europe(developing only) to that in European Union?
Offer a very short reply. 0.49. What is the ratio of the Number of enrolments of both sexes in Secondary in Europe(developing only) to that in European Union?
Make the answer very short. 0.48. What is the ratio of the Number of enrolments of both sexes of Secondary general in Europe(developing only) to that in European Union?
Keep it short and to the point. 0.55. What is the ratio of the Number of enrolments of both sexes in Secondary vocational in Europe(developing only) to that in European Union?
Your response must be concise. 0.29. What is the ratio of the Number of enrolments of both sexes of Primary in Europe(developing only) to that in Fragile and conflict affected situations?
Keep it short and to the point. 0.6. What is the ratio of the Number of enrolments of both sexes of Secondary in Europe(developing only) to that in Fragile and conflict affected situations?
Offer a very short reply. 2.59. What is the ratio of the Number of enrolments of both sexes in Secondary general in Europe(developing only) to that in Fragile and conflict affected situations?
Keep it short and to the point. 2.38. What is the ratio of the Number of enrolments of both sexes of Secondary vocational in Europe(developing only) to that in Fragile and conflict affected situations?
Your response must be concise. 4.37. What is the ratio of the Number of enrolments of both sexes in Primary in European Union to that in Fragile and conflict affected situations?
Your answer should be compact. 1.24. What is the ratio of the Number of enrolments of both sexes of Secondary in European Union to that in Fragile and conflict affected situations?
Provide a succinct answer. 5.4. What is the ratio of the Number of enrolments of both sexes of Secondary general in European Union to that in Fragile and conflict affected situations?
Keep it short and to the point. 4.3. What is the ratio of the Number of enrolments of both sexes of Secondary vocational in European Union to that in Fragile and conflict affected situations?
Ensure brevity in your answer.  14.99. What is the difference between the highest and the second highest Number of enrolments of both sexes of Primary?
Keep it short and to the point. 1.49e+08. What is the difference between the highest and the second highest Number of enrolments of both sexes of Secondary?
Your response must be concise. 1.09e+07. What is the difference between the highest and the second highest Number of enrolments of both sexes in Secondary general?
Make the answer very short. 4.03e+06. What is the difference between the highest and the second highest Number of enrolments of both sexes of Secondary vocational?
Provide a succinct answer. 4.64e+06. What is the difference between the highest and the lowest Number of enrolments of both sexes in Primary?
Ensure brevity in your answer.  1.89e+08. What is the difference between the highest and the lowest Number of enrolments of both sexes in Secondary?
Your answer should be compact. 7.18e+07. What is the difference between the highest and the lowest Number of enrolments of both sexes in Secondary general?
Keep it short and to the point. 5.86e+07. What is the difference between the highest and the lowest Number of enrolments of both sexes of Secondary vocational?
Provide a short and direct response. 1.72e+07. 